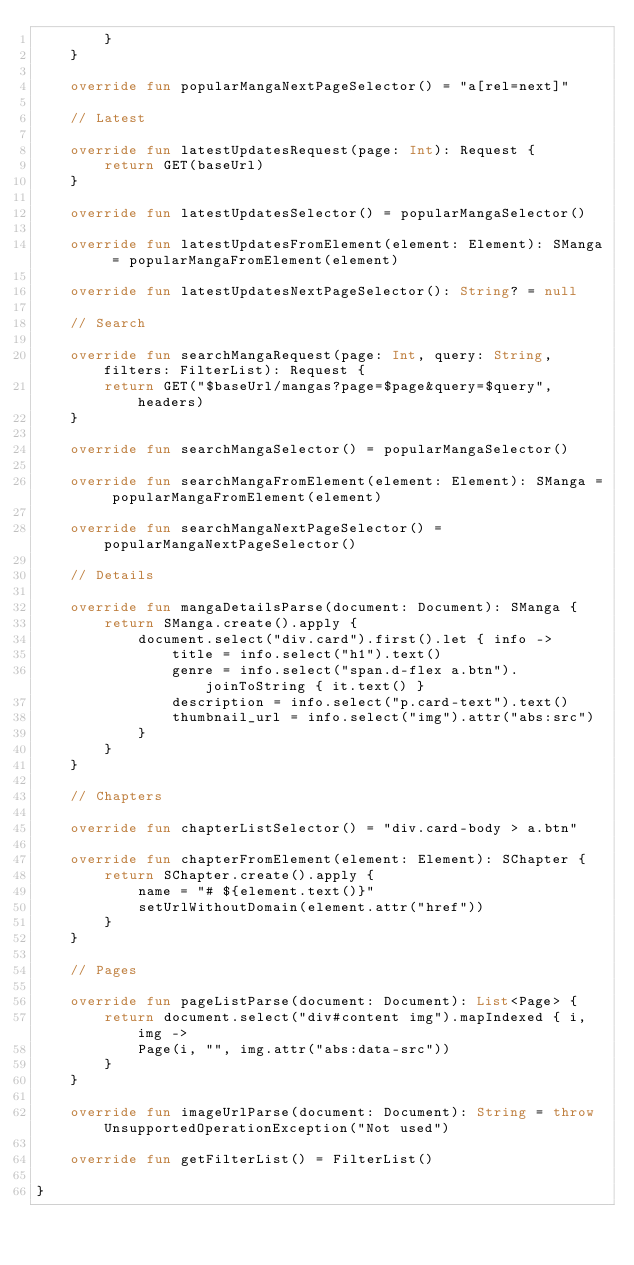Convert code to text. <code><loc_0><loc_0><loc_500><loc_500><_Kotlin_>        }
    }

    override fun popularMangaNextPageSelector() = "a[rel=next]"

    // Latest

    override fun latestUpdatesRequest(page: Int): Request {
        return GET(baseUrl)
    }

    override fun latestUpdatesSelector() = popularMangaSelector()

    override fun latestUpdatesFromElement(element: Element): SManga = popularMangaFromElement(element)

    override fun latestUpdatesNextPageSelector(): String? = null

    // Search

    override fun searchMangaRequest(page: Int, query: String, filters: FilterList): Request {
        return GET("$baseUrl/mangas?page=$page&query=$query", headers)
    }

    override fun searchMangaSelector() = popularMangaSelector()

    override fun searchMangaFromElement(element: Element): SManga = popularMangaFromElement(element)

    override fun searchMangaNextPageSelector() = popularMangaNextPageSelector()

    // Details

    override fun mangaDetailsParse(document: Document): SManga {
        return SManga.create().apply {
            document.select("div.card").first().let { info ->
                title = info.select("h1").text()
                genre = info.select("span.d-flex a.btn").joinToString { it.text() }
                description = info.select("p.card-text").text()
                thumbnail_url = info.select("img").attr("abs:src")
            }
        }
    }

    // Chapters

    override fun chapterListSelector() = "div.card-body > a.btn"

    override fun chapterFromElement(element: Element): SChapter {
        return SChapter.create().apply {
            name = "# ${element.text()}"
            setUrlWithoutDomain(element.attr("href"))
        }
    }

    // Pages

    override fun pageListParse(document: Document): List<Page> {
        return document.select("div#content img").mapIndexed { i, img ->
            Page(i, "", img.attr("abs:data-src"))
        }
    }

    override fun imageUrlParse(document: Document): String = throw UnsupportedOperationException("Not used")

    override fun getFilterList() = FilterList()

}
</code> 